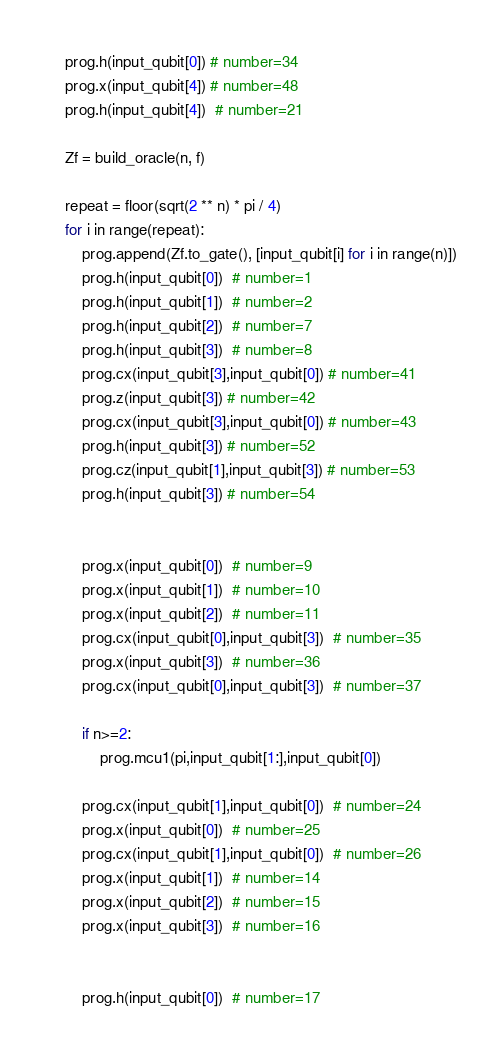<code> <loc_0><loc_0><loc_500><loc_500><_Python_>    prog.h(input_qubit[0]) # number=34
    prog.x(input_qubit[4]) # number=48
    prog.h(input_qubit[4])  # number=21

    Zf = build_oracle(n, f)

    repeat = floor(sqrt(2 ** n) * pi / 4)
    for i in range(repeat):
        prog.append(Zf.to_gate(), [input_qubit[i] for i in range(n)])
        prog.h(input_qubit[0])  # number=1
        prog.h(input_qubit[1])  # number=2
        prog.h(input_qubit[2])  # number=7
        prog.h(input_qubit[3])  # number=8
        prog.cx(input_qubit[3],input_qubit[0]) # number=41
        prog.z(input_qubit[3]) # number=42
        prog.cx(input_qubit[3],input_qubit[0]) # number=43
        prog.h(input_qubit[3]) # number=52
        prog.cz(input_qubit[1],input_qubit[3]) # number=53
        prog.h(input_qubit[3]) # number=54


        prog.x(input_qubit[0])  # number=9
        prog.x(input_qubit[1])  # number=10
        prog.x(input_qubit[2])  # number=11
        prog.cx(input_qubit[0],input_qubit[3])  # number=35
        prog.x(input_qubit[3])  # number=36
        prog.cx(input_qubit[0],input_qubit[3])  # number=37

        if n>=2:
            prog.mcu1(pi,input_qubit[1:],input_qubit[0])

        prog.cx(input_qubit[1],input_qubit[0])  # number=24
        prog.x(input_qubit[0])  # number=25
        prog.cx(input_qubit[1],input_qubit[0])  # number=26
        prog.x(input_qubit[1])  # number=14
        prog.x(input_qubit[2])  # number=15
        prog.x(input_qubit[3])  # number=16


        prog.h(input_qubit[0])  # number=17</code> 